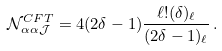Convert formula to latex. <formula><loc_0><loc_0><loc_500><loc_500>\mathcal { N } ^ { C F T } _ { \alpha \alpha \mathcal { J } } = 4 ( 2 \delta - 1 ) \frac { \ell ! ( \delta ) _ { \ell } } { ( 2 \delta - 1 ) _ { \ell } } \, .</formula> 